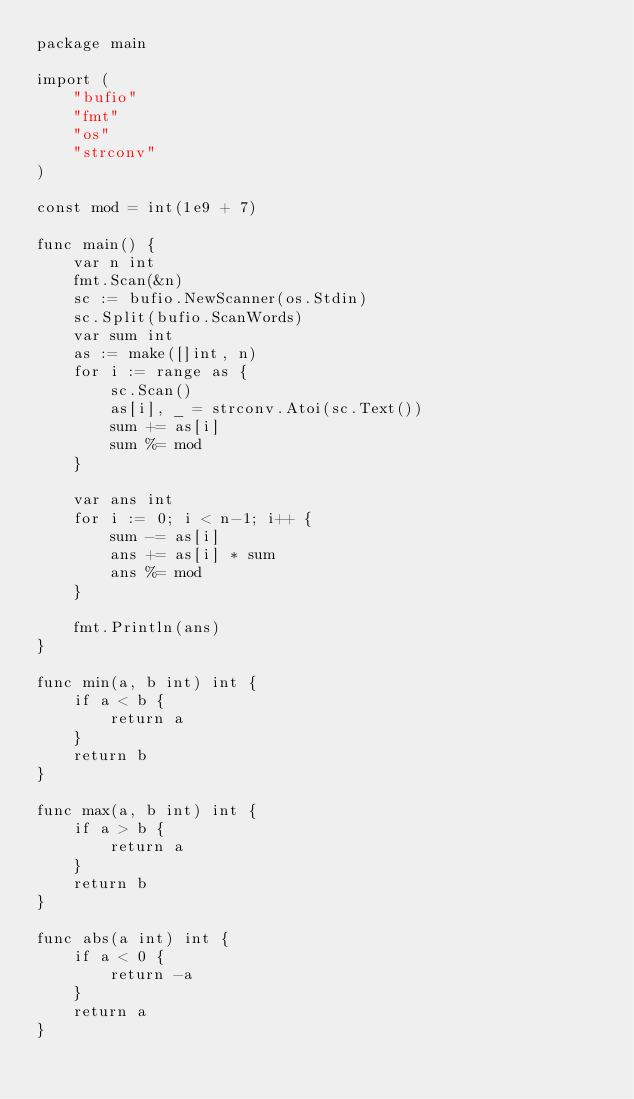<code> <loc_0><loc_0><loc_500><loc_500><_Go_>package main

import (
	"bufio"
	"fmt"
	"os"
	"strconv"
)

const mod = int(1e9 + 7)

func main() {
	var n int
	fmt.Scan(&n)
	sc := bufio.NewScanner(os.Stdin)
	sc.Split(bufio.ScanWords)
	var sum int
	as := make([]int, n)
	for i := range as {
		sc.Scan()
		as[i], _ = strconv.Atoi(sc.Text())
		sum += as[i]
		sum %= mod
	}

	var ans int
	for i := 0; i < n-1; i++ {
		sum -= as[i]
		ans += as[i] * sum
		ans %= mod
	}

	fmt.Println(ans)
}

func min(a, b int) int {
	if a < b {
		return a
	}
	return b
}

func max(a, b int) int {
	if a > b {
		return a
	}
	return b
}

func abs(a int) int {
	if a < 0 {
		return -a
	}
	return a
}
</code> 